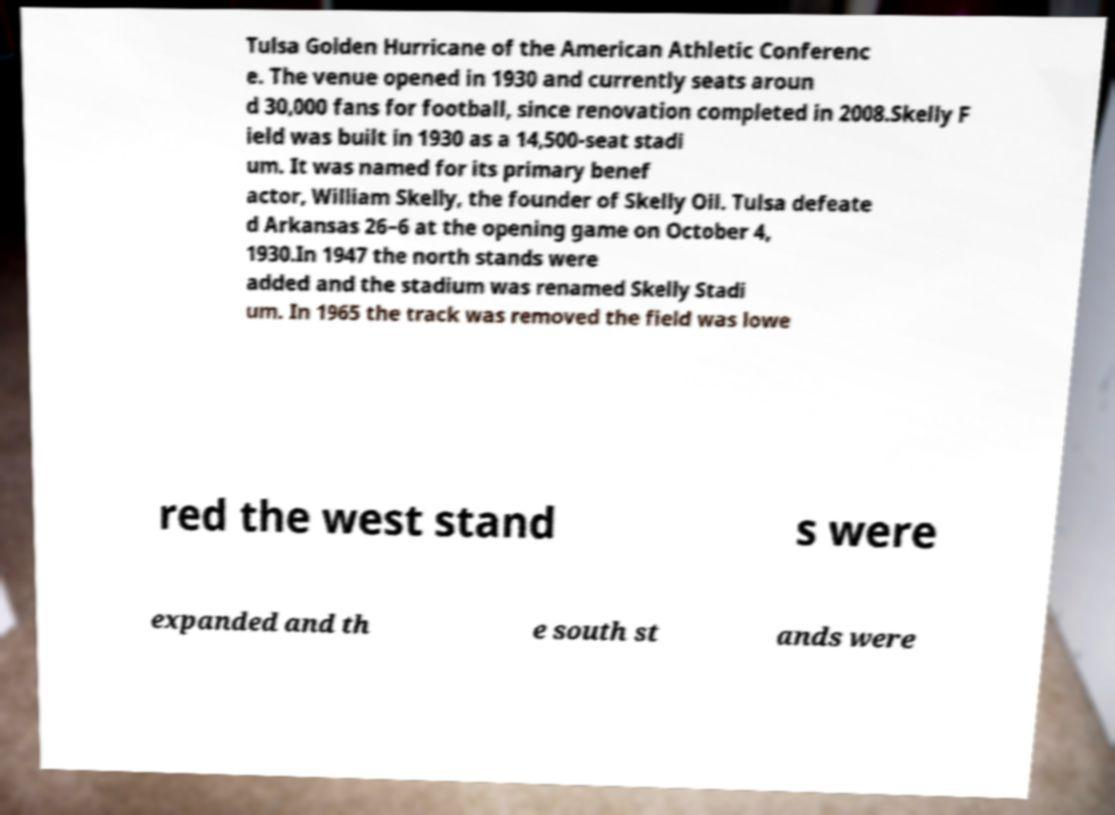Please read and relay the text visible in this image. What does it say? Tulsa Golden Hurricane of the American Athletic Conferenc e. The venue opened in 1930 and currently seats aroun d 30,000 fans for football, since renovation completed in 2008.Skelly F ield was built in 1930 as a 14,500-seat stadi um. It was named for its primary benef actor, William Skelly, the founder of Skelly Oil. Tulsa defeate d Arkansas 26–6 at the opening game on October 4, 1930.In 1947 the north stands were added and the stadium was renamed Skelly Stadi um. In 1965 the track was removed the field was lowe red the west stand s were expanded and th e south st ands were 